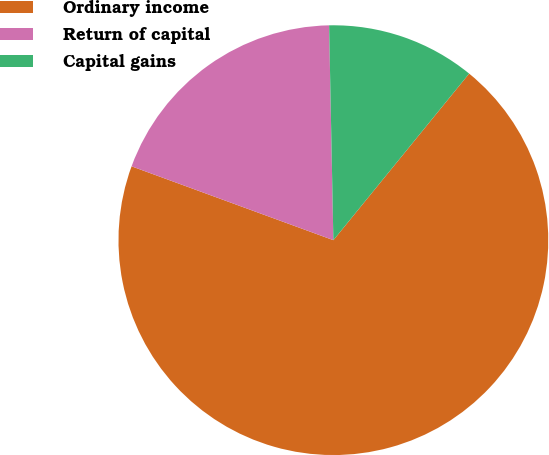Convert chart. <chart><loc_0><loc_0><loc_500><loc_500><pie_chart><fcel>Ordinary income<fcel>Return of capital<fcel>Capital gains<nl><fcel>69.7%<fcel>19.1%<fcel>11.2%<nl></chart> 